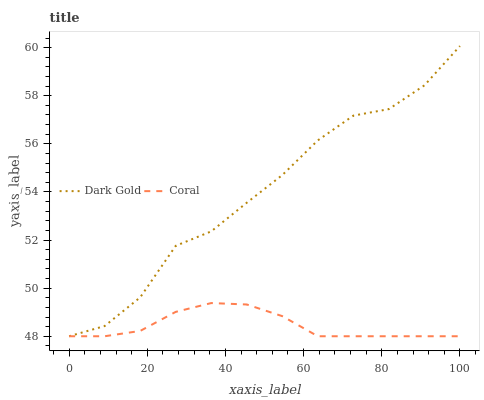Does Dark Gold have the minimum area under the curve?
Answer yes or no. No. Is Dark Gold the smoothest?
Answer yes or no. No. 